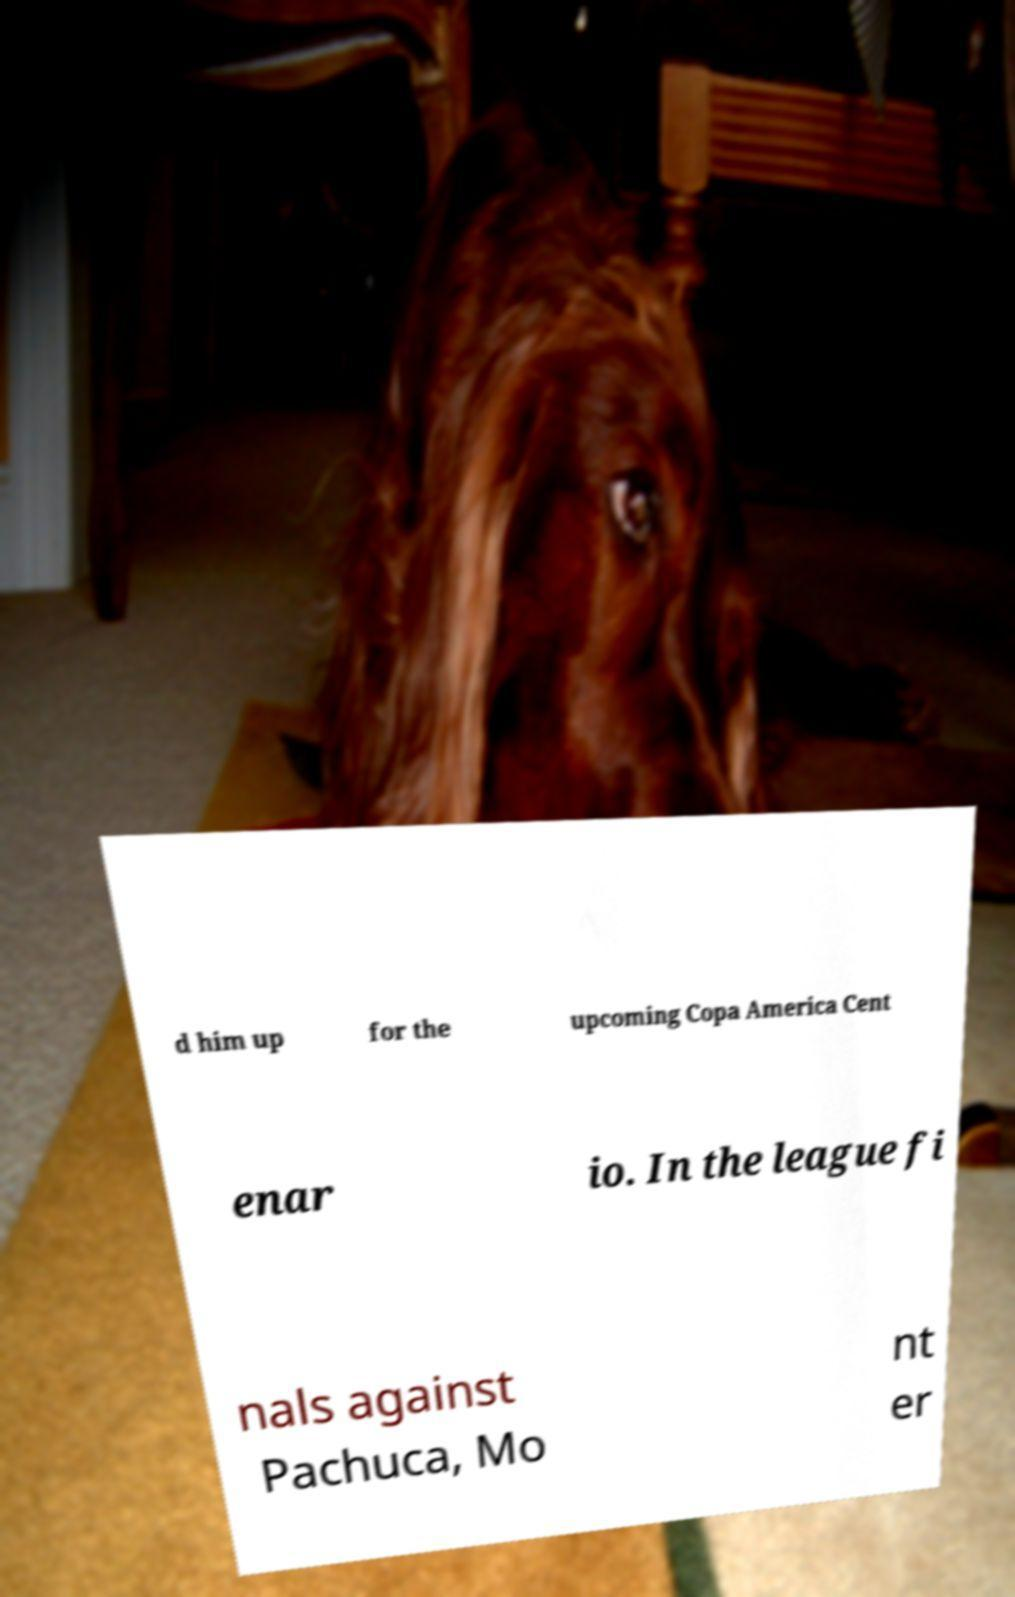Can you read and provide the text displayed in the image?This photo seems to have some interesting text. Can you extract and type it out for me? d him up for the upcoming Copa America Cent enar io. In the league fi nals against Pachuca, Mo nt er 